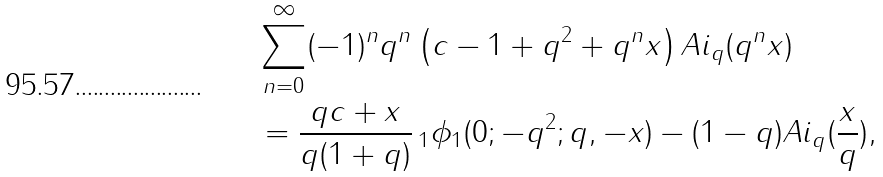Convert formula to latex. <formula><loc_0><loc_0><loc_500><loc_500>& \sum _ { n = 0 } ^ { \infty } ( - 1 ) ^ { n } q ^ { n } \left ( c - 1 + q ^ { 2 } + q ^ { n } x \right ) A i _ { q } ( q ^ { n } x ) \\ & = \frac { q c + x } { q ( 1 + q ) } \, _ { 1 } \phi _ { 1 } ( 0 ; - q ^ { 2 } ; q , - x ) - ( 1 - q ) A i _ { q } ( \frac { x } { q } ) ,</formula> 